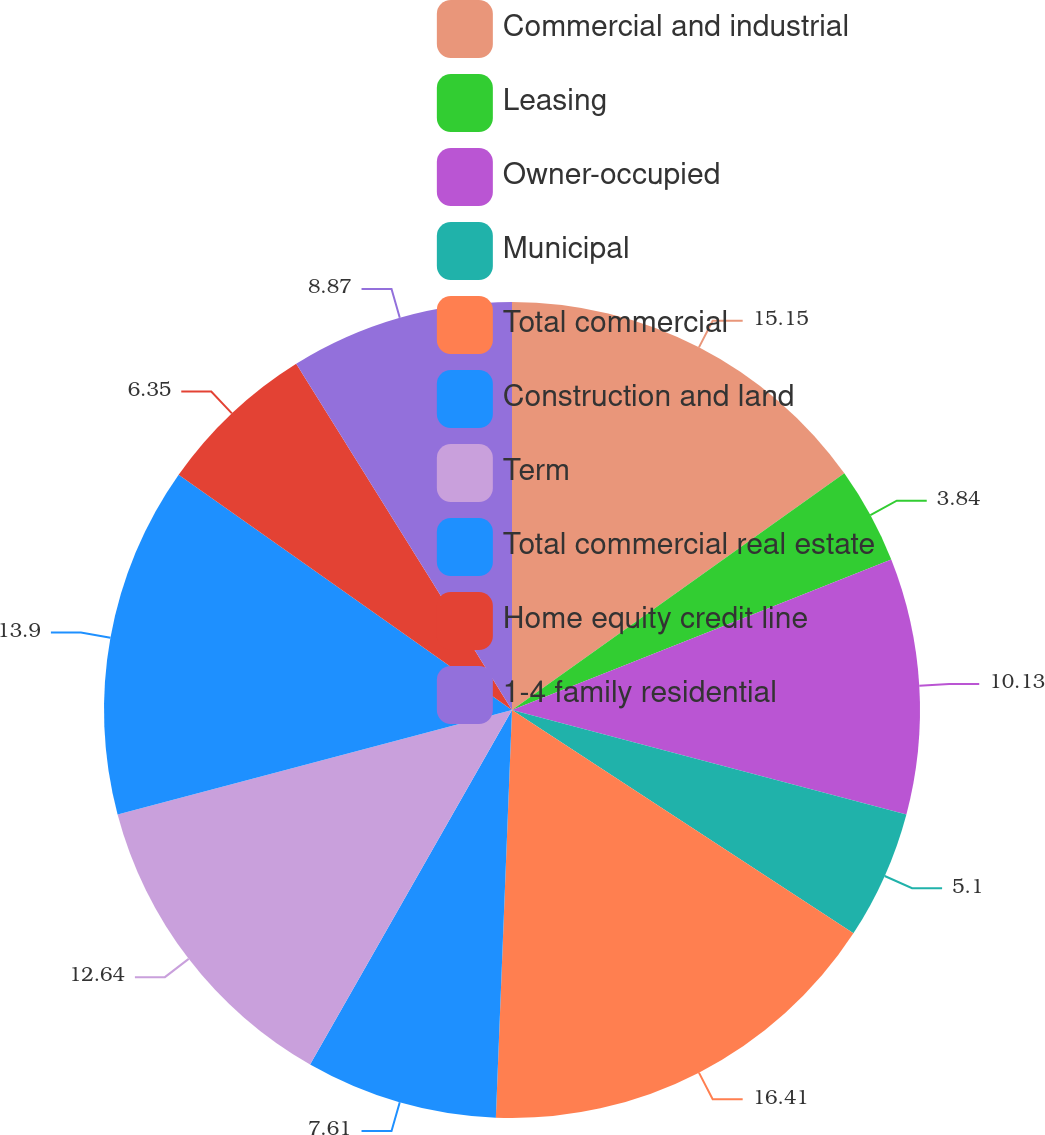<chart> <loc_0><loc_0><loc_500><loc_500><pie_chart><fcel>Commercial and industrial<fcel>Leasing<fcel>Owner-occupied<fcel>Municipal<fcel>Total commercial<fcel>Construction and land<fcel>Term<fcel>Total commercial real estate<fcel>Home equity credit line<fcel>1-4 family residential<nl><fcel>15.15%<fcel>3.84%<fcel>10.13%<fcel>5.1%<fcel>16.41%<fcel>7.61%<fcel>12.64%<fcel>13.9%<fcel>6.35%<fcel>8.87%<nl></chart> 